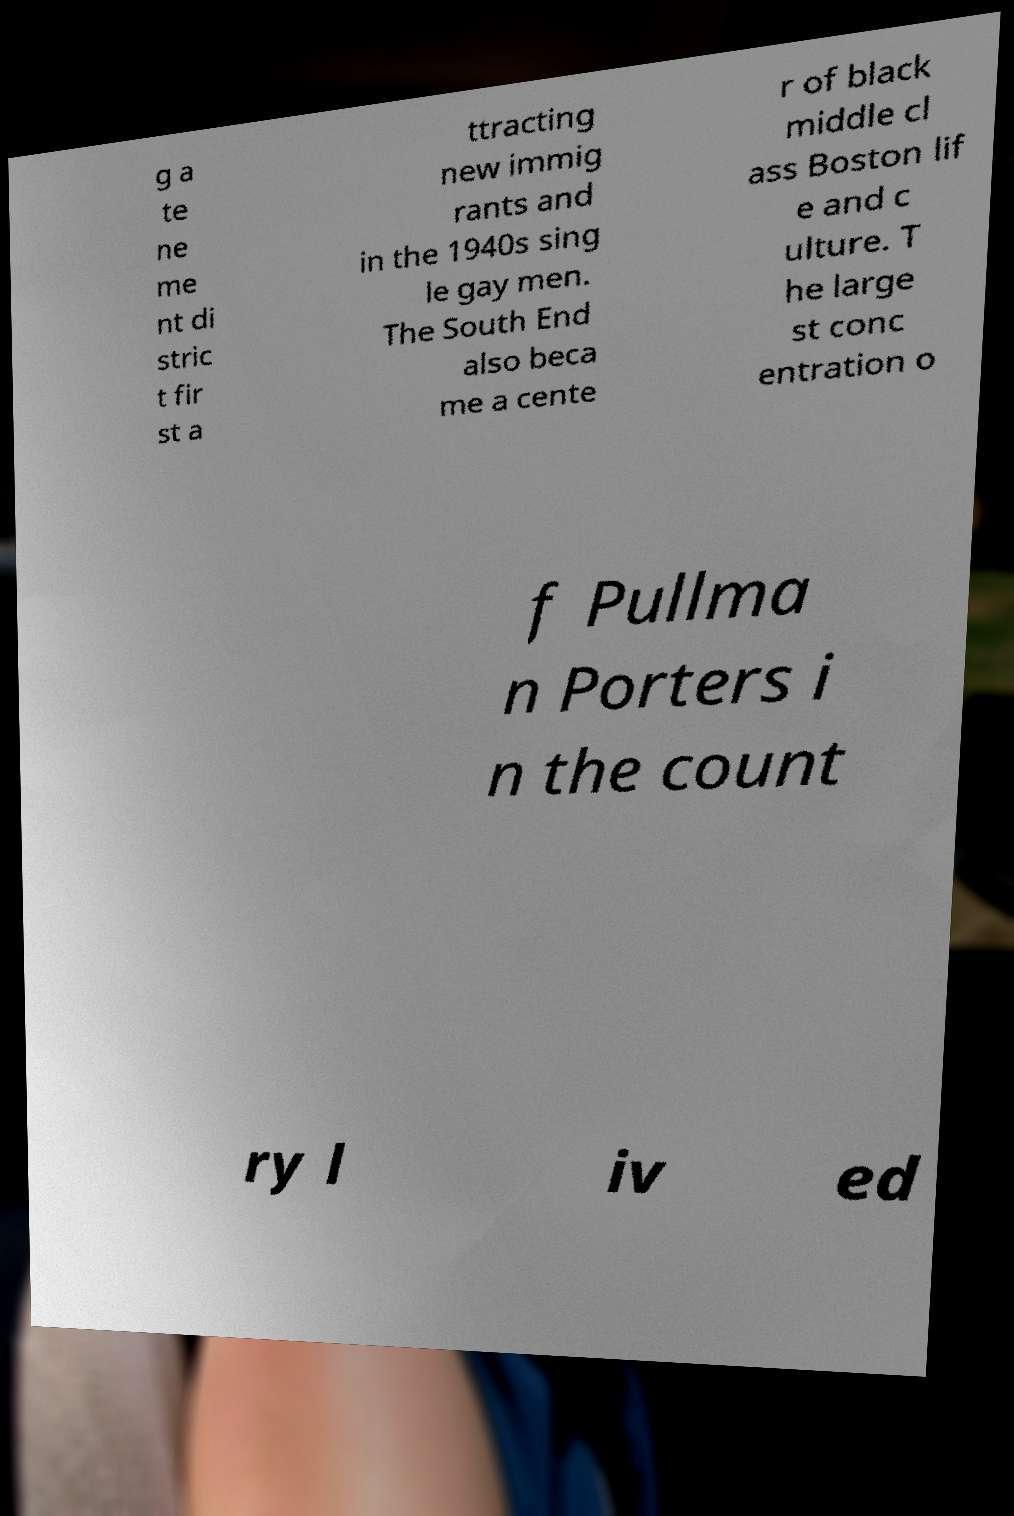Please read and relay the text visible in this image. What does it say? g a te ne me nt di stric t fir st a ttracting new immig rants and in the 1940s sing le gay men. The South End also beca me a cente r of black middle cl ass Boston lif e and c ulture. T he large st conc entration o f Pullma n Porters i n the count ry l iv ed 